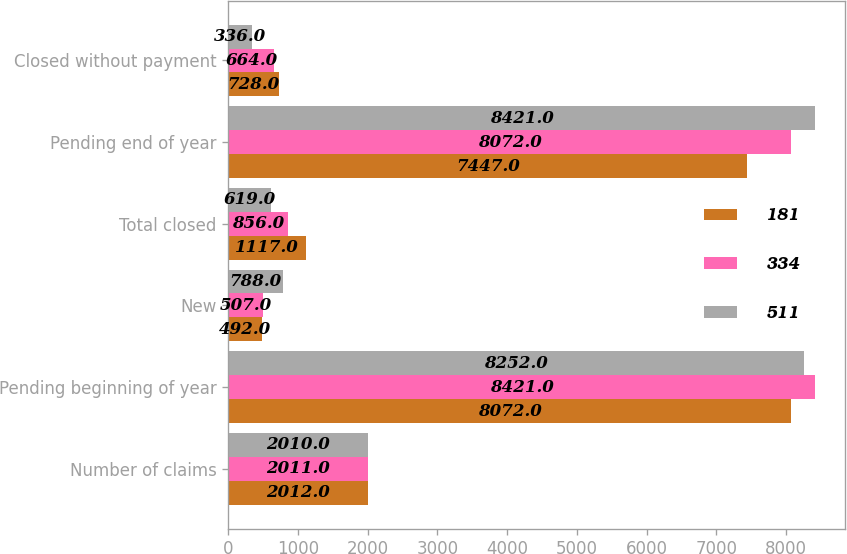Convert chart. <chart><loc_0><loc_0><loc_500><loc_500><stacked_bar_chart><ecel><fcel>Number of claims<fcel>Pending beginning of year<fcel>New<fcel>Total closed<fcel>Pending end of year<fcel>Closed without payment<nl><fcel>181<fcel>2012<fcel>8072<fcel>492<fcel>1117<fcel>7447<fcel>728<nl><fcel>334<fcel>2011<fcel>8421<fcel>507<fcel>856<fcel>8072<fcel>664<nl><fcel>511<fcel>2010<fcel>8252<fcel>788<fcel>619<fcel>8421<fcel>336<nl></chart> 